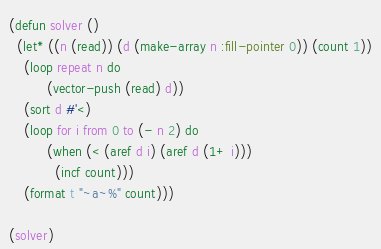Convert code to text. <code><loc_0><loc_0><loc_500><loc_500><_Lisp_>(defun solver ()
  (let* ((n (read)) (d (make-array n :fill-pointer 0)) (count 1))
    (loop repeat n do
          (vector-push (read) d))
    (sort d #'<)
    (loop for i from 0 to (- n 2) do
          (when (< (aref d i) (aref d (1+ i)))
            (incf count)))
    (format t "~a~%" count)))

(solver)</code> 